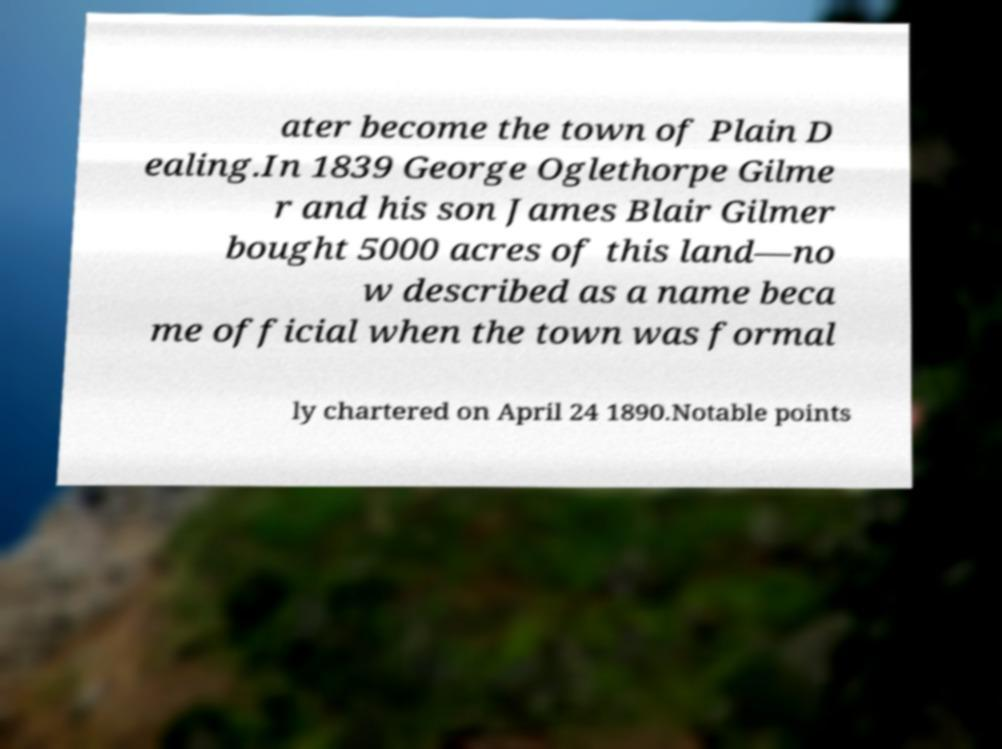What messages or text are displayed in this image? I need them in a readable, typed format. ater become the town of Plain D ealing.In 1839 George Oglethorpe Gilme r and his son James Blair Gilmer bought 5000 acres of this land—no w described as a name beca me official when the town was formal ly chartered on April 24 1890.Notable points 